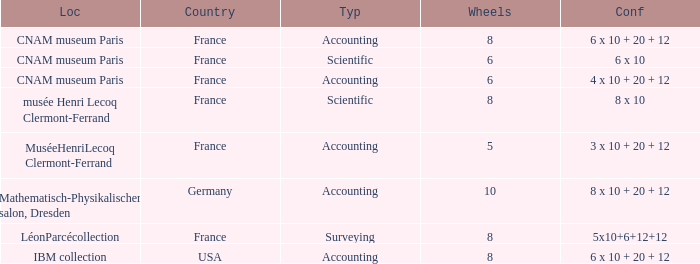What average wheels has accounting as the type, with IBM Collection as the location? 8.0. Can you parse all the data within this table? {'header': ['Loc', 'Country', 'Typ', 'Wheels', 'Conf'], 'rows': [['CNAM museum Paris', 'France', 'Accounting', '8', '6 x 10 + 20 + 12'], ['CNAM museum Paris', 'France', 'Scientific', '6', '6 x 10'], ['CNAM museum Paris', 'France', 'Accounting', '6', '4 x 10 + 20 + 12'], ['musée Henri Lecoq Clermont-Ferrand', 'France', 'Scientific', '8', '8 x 10'], ['MuséeHenriLecoq Clermont-Ferrand', 'France', 'Accounting', '5', '3 x 10 + 20 + 12'], ['Mathematisch-Physikalischer salon, Dresden', 'Germany', 'Accounting', '10', '8 x 10 + 20 + 12'], ['LéonParcécollection', 'France', 'Surveying', '8', '5x10+6+12+12'], ['IBM collection', 'USA', 'Accounting', '8', '6 x 10 + 20 + 12']]} 